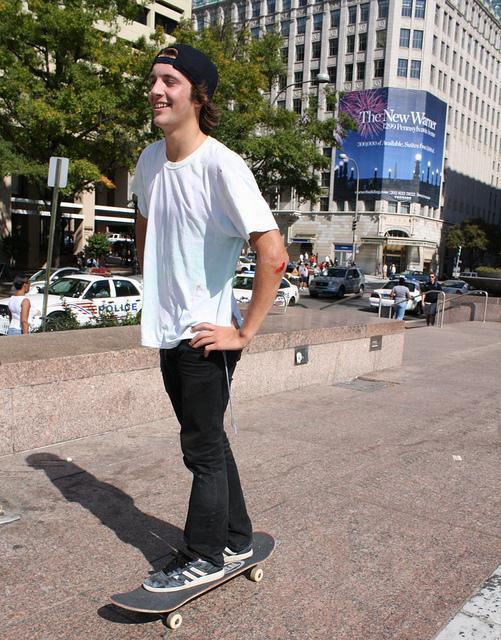What type of shoes is the boy wearing?
Choose the right answer from the provided options to respond to the question.
Options: Adidas, jordan, reebok, nike. Adidas. 